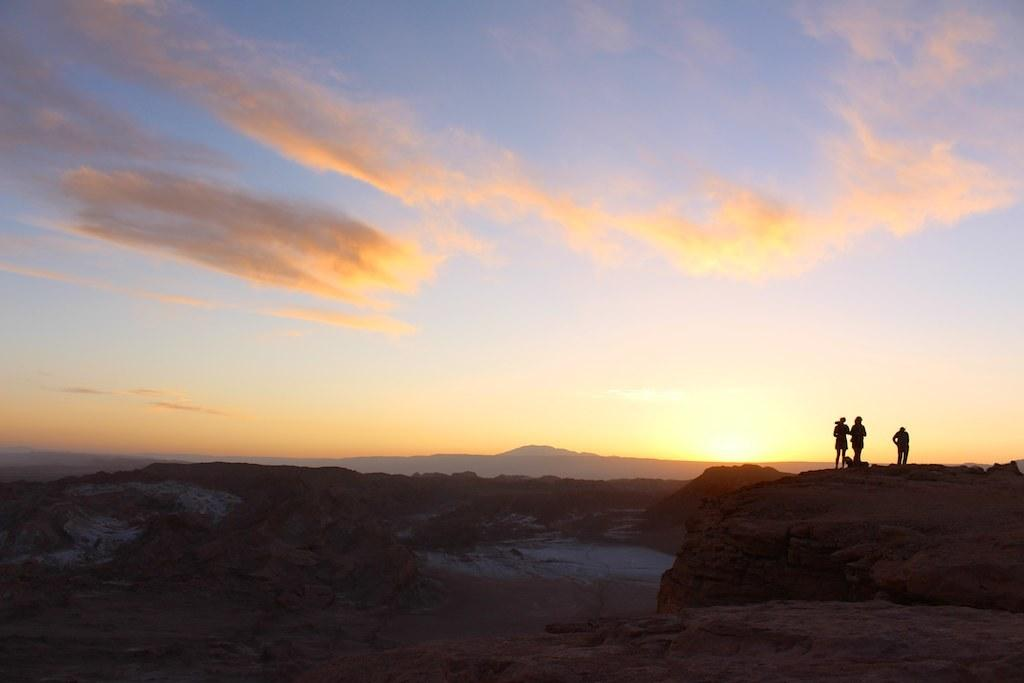How many people are in the image? There are three persons in the image. What are the persons standing on? The persons are standing on rocks. What can be seen in the background of the image? There is a sky visible in the background of the image. What type of thread is being used by the persons in the image? There is no thread visible in the image; the persons are standing on rocks. 